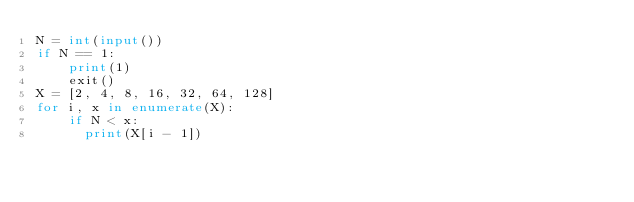Convert code to text. <code><loc_0><loc_0><loc_500><loc_500><_Python_>N = int(input())
if N == 1:
    print(1)
    exit()
X = [2, 4, 8, 16, 32, 64, 128]
for i, x in enumerate(X):
    if N < x:
      print(X[i - 1])
</code> 